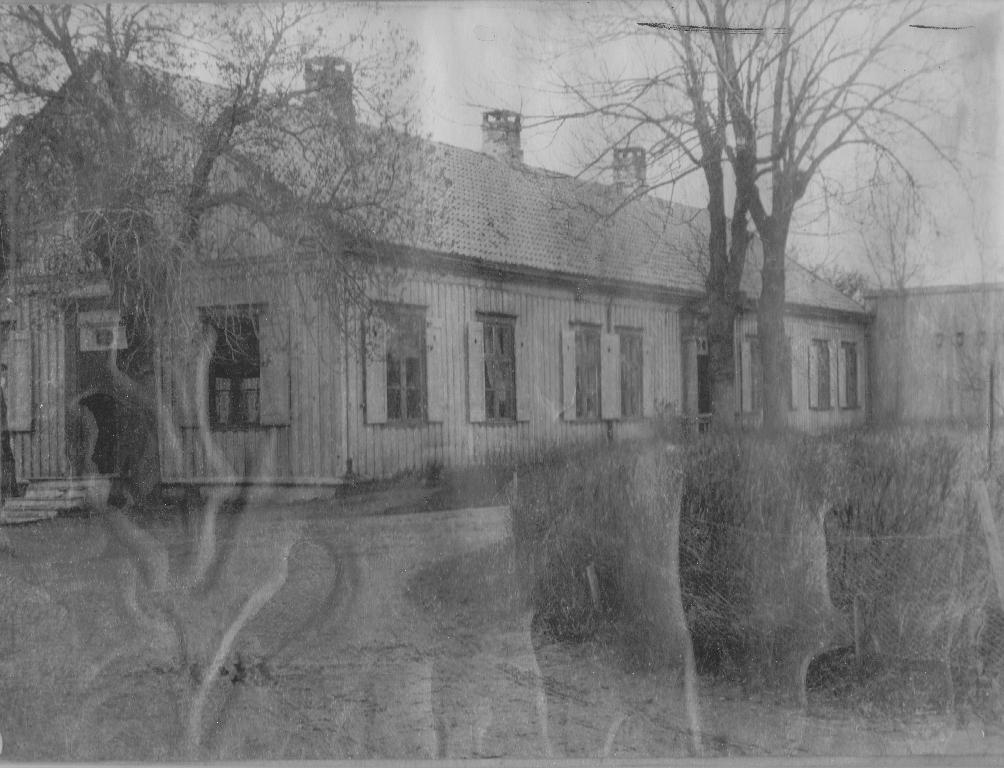What type of structure is present in the image? There is a building in the image. What can be seen on the building in the image? There are windows visible in the image. What type of natural elements are present in the image? There are trees and plants in the image. What is visible at the bottom of the image? The ground is visible in the image. What is visible at the top of the image? The sky is visible in the image. How many cent coins are scattered on the ground in the image? There are no cent coins present in the image. Can you see a cat climbing the building in the image? There is no cat present in the image. 